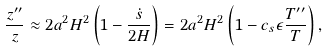<formula> <loc_0><loc_0><loc_500><loc_500>\frac { z ^ { \prime \prime } } { z } \approx 2 a ^ { 2 } H ^ { 2 } \left ( 1 - \frac { \dot { s } } { 2 H } \right ) = 2 a ^ { 2 } H ^ { 2 } \left ( 1 - c _ { s } \epsilon \frac { T ^ { \prime \prime } } { T } \right ) ,</formula> 